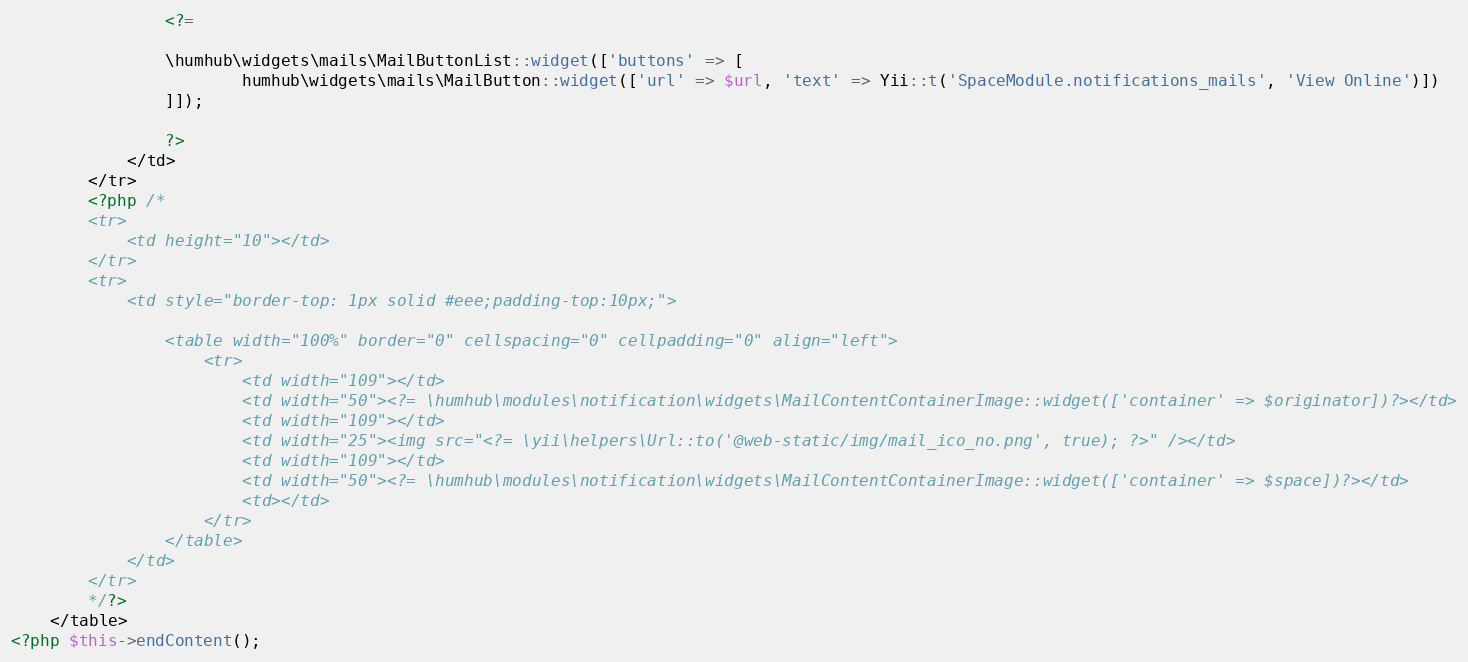<code> <loc_0><loc_0><loc_500><loc_500><_PHP_>                <?=

                \humhub\widgets\mails\MailButtonList::widget(['buttons' => [
                        humhub\widgets\mails\MailButton::widget(['url' => $url, 'text' => Yii::t('SpaceModule.notifications_mails', 'View Online')])
                ]]);

                ?>
            </td>
        </tr>
        <?php /*
        <tr>
            <td height="10"></td>
        </tr>
        <tr>
            <td style="border-top: 1px solid #eee;padding-top:10px;">

                <table width="100%" border="0" cellspacing="0" cellpadding="0" align="left">
                    <tr>
                        <td width="109"></td>
                        <td width="50"><?= \humhub\modules\notification\widgets\MailContentContainerImage::widget(['container' => $originator])?></td>
                        <td width="109"></td>
                        <td width="25"><img src="<?= \yii\helpers\Url::to('@web-static/img/mail_ico_no.png', true); ?>" /></td>
                        <td width="109"></td>
                        <td width="50"><?= \humhub\modules\notification\widgets\MailContentContainerImage::widget(['container' => $space])?></td>
                        <td></td>
                    </tr>
                </table>
            </td>
        </tr>
        */?>
    </table>
<?php $this->endContent();</code> 